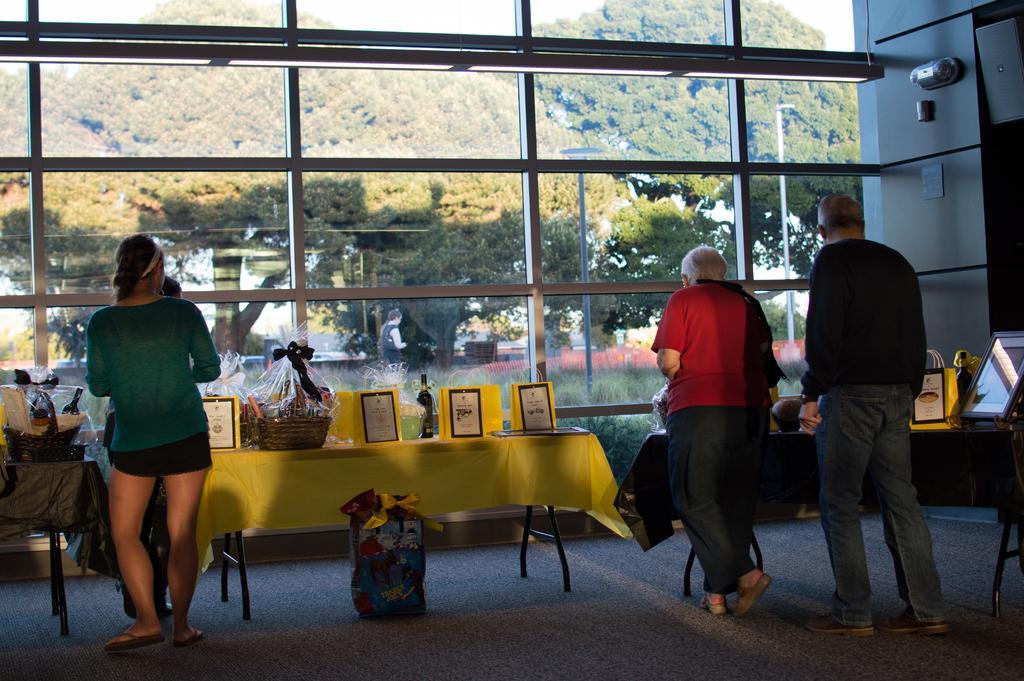In one or two sentences, can you explain what this image depicts? In the left bottom of the image, two womens are standing. In the right bottom of the image two persons are walking. In front of that, there is a table on which white colored cloth is covered and basket and trophies are kept on that. In the top of the image, sky is visible and trees are visible. In the background, there is a glass window. In the background, houses are there. This image is taken inside the house. 